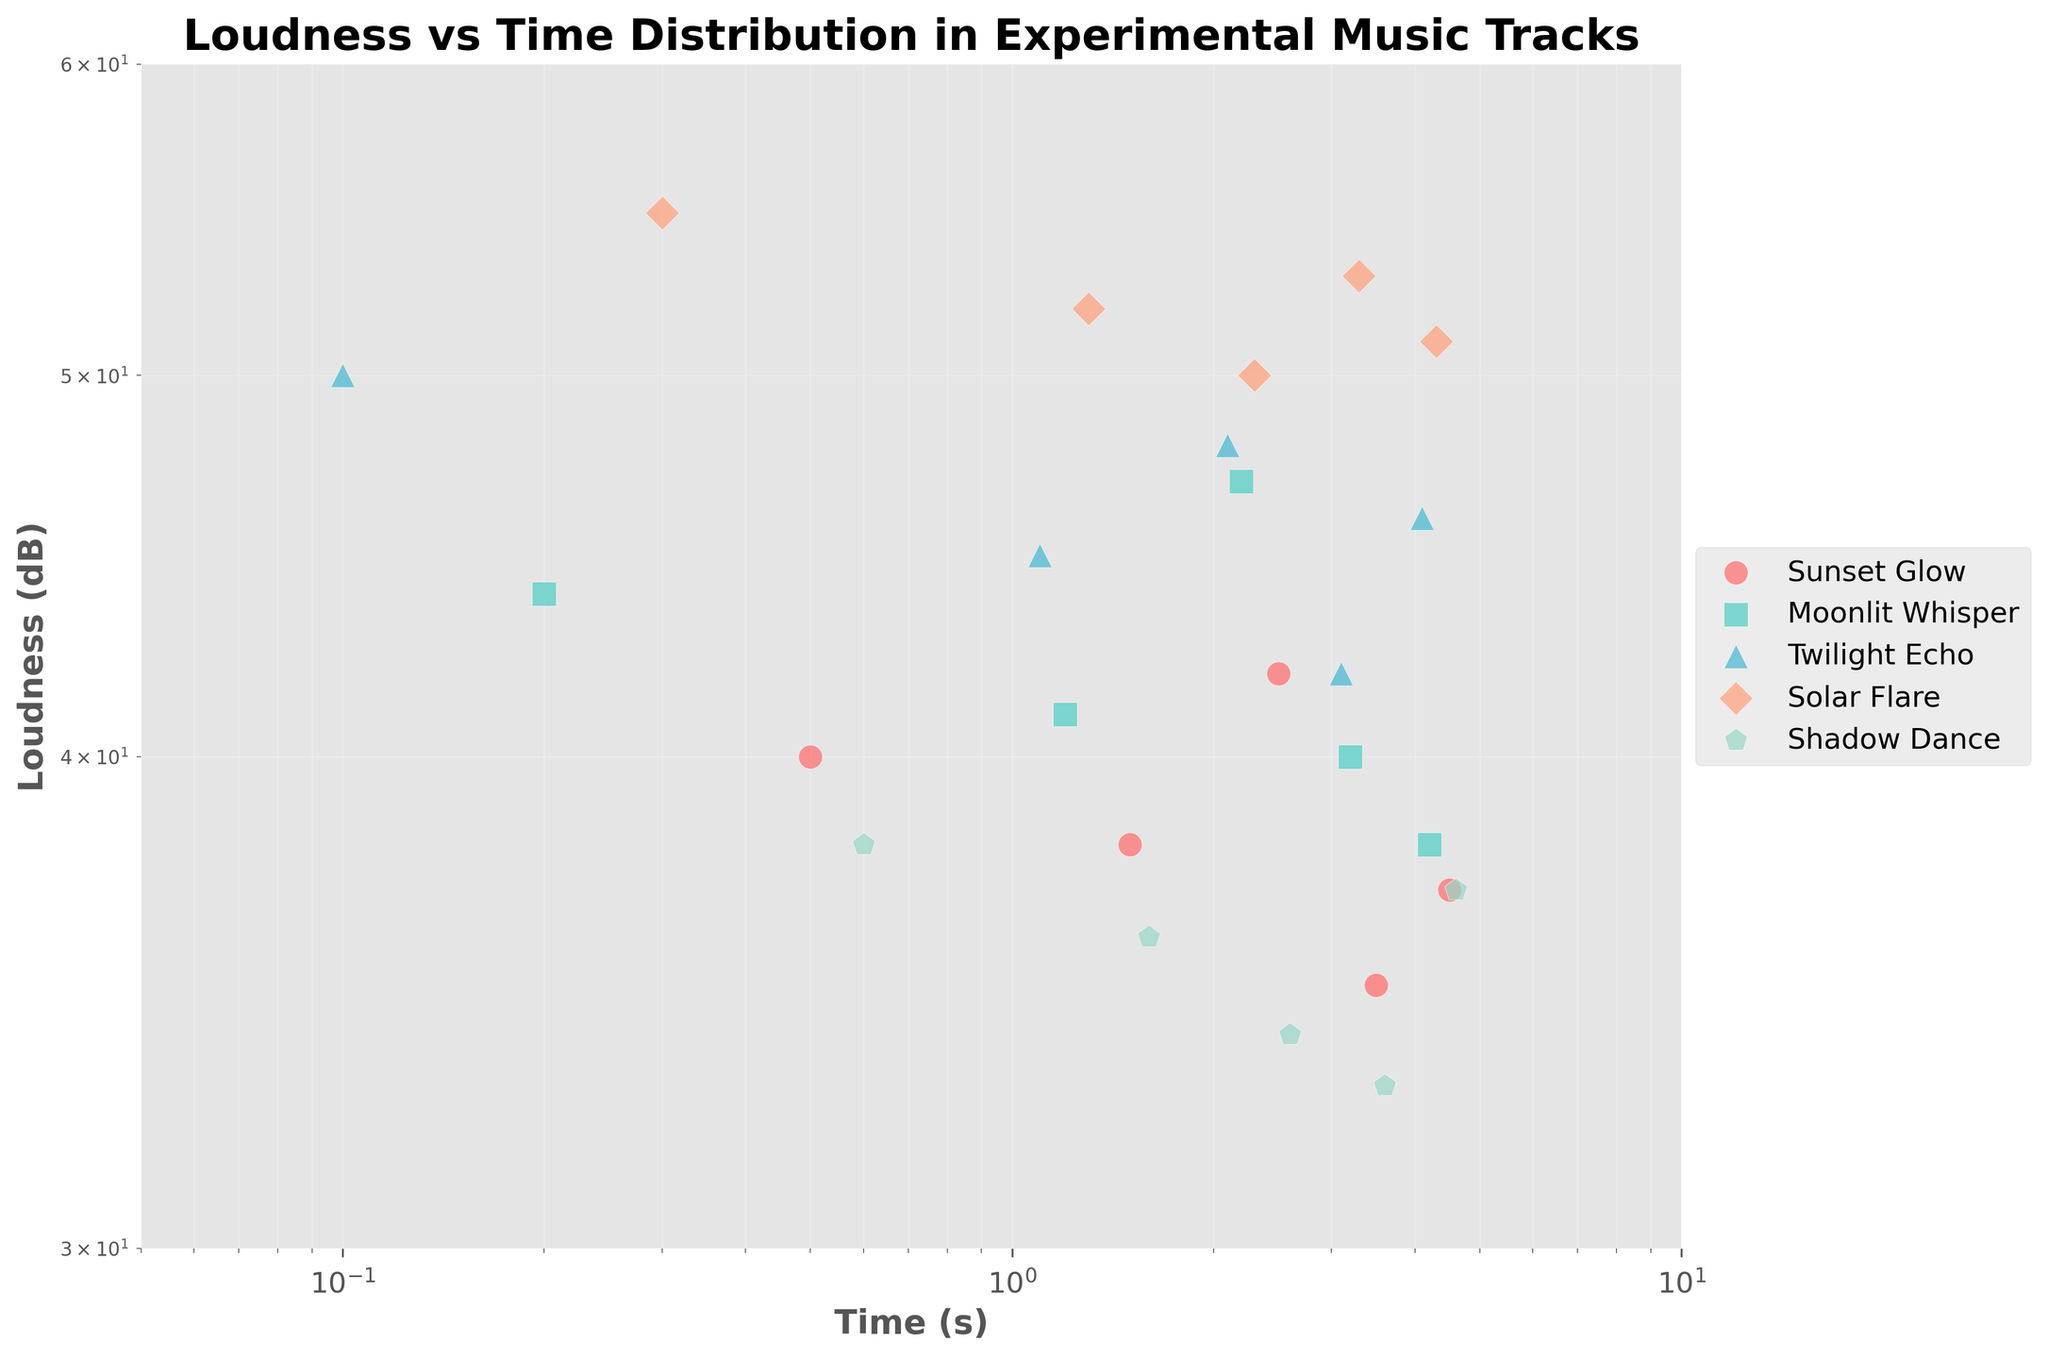What is the title of the scatter plot? The title is located at the top of the plot and describes the main content of the visualization.
Answer: Loudness vs Time Distribution in Experimental Music Tracks Which track has the loudest sound at the earliest time point? To find this, look at the data points with the smallest Time (s) values (closer to the left) and check their corresponding Loudness (dB) values. The smallest time with the highest Loudness (dB) would be around 0.5s with -40 dB from "Sunset Glow."
Answer: Sunset Glow How does the loudness trend over time for the track "Shadow Dance"? Observe the scatter points for "Shadow Dance," which uses a specific color and marker. Note their positions along the Time (s) and Loudness (dB) axes to infer the trend. The loudness seems to increase from -38 dB at 0.6s to -33 dB at 3.6s and then slightly decreases to -37 dB at 4.6s.
Answer: Increases then decreases Which track maintains a fairly consistent loudness over time? Look for a track whose scatter points remain relatively horizontal over time, indicating little variation in Loudness (dB) regardless of Time (s). "Solar Flare" maintains loudness around -50 dB to -55 dB consistently.
Answer: Solar Flare What is the overall range of loudness values for all tracks combined? Examine the vertical spread of scatter points across all colors and markers. Identify the highest and lowest Loudness (dB) values. The range spans from -33 dB (Shadow Dance) to -55 dB (Solar Flare).
Answer: -22 dB How does the loudness of "Twilight Echo" compare between 2.1s and 4.1s? Locate the points for "Twilight Echo" at these specific Time (s) values. Compare their Loudness (dB) values. "Twilight Echo" has a loudness of -48 dB at 2.1s and -46 dB at 4.1s.
Answer: Louder at 4.1s Which track shows the most rapid increase in loudness from the earliest to the latest time point? Compare the change in Loudness (dB) for each track from their earliest to latest Time (s) values. "Shadow Dance" shows a notable increase from -38 dB to -33 dB within the time range.
Answer: Shadow Dance Between "Sunset Glow" and "Moonlit Whisper," which has a more variable loudness trend? Examine the scatter points for both tracks. Observe which has a broader spread along the Loudness (dB) axis. "Moonlit Whisper" ranges more widely from -47 dB to -38 dB compared to "Sunset Glow," which varies between -42 dB to -35 dB.
Answer: Moonlit Whisper What do the x and y axes represent in this plot? The axes labels are written along the respective directions. The x-axis represents Time (s), and the y-axis represents Loudness (dB).
Answer: Time (s) and Loudness (dB) 